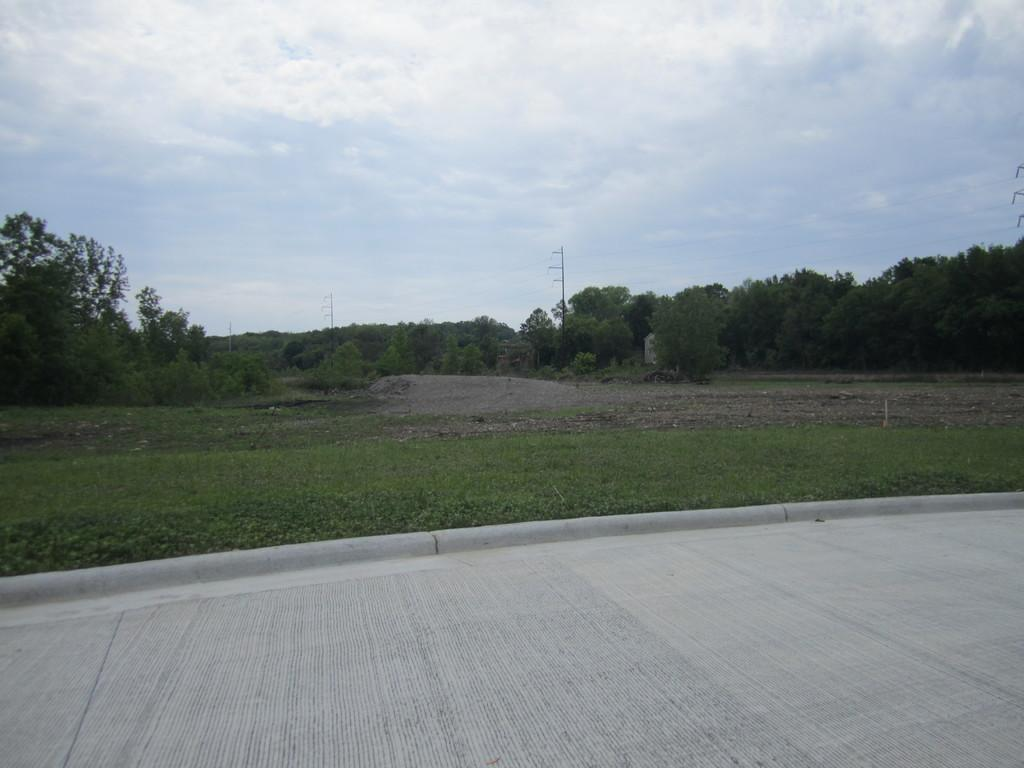What is the main feature of the landscape in the picture? There is a road in the picture. What type of vegetation can be seen on the ground? There is grass on the floor. What other natural elements are present in the picture? There are trees in the picture. How would you describe the weather based on the sky in the picture? The sky is clear in the picture, suggesting good weather. What type of work is being done on the road in the picture? There is no indication of any work being done on the road in the picture. Can you see any signs of a fire or burn in the picture? There is no fire or burn visible in the picture. 